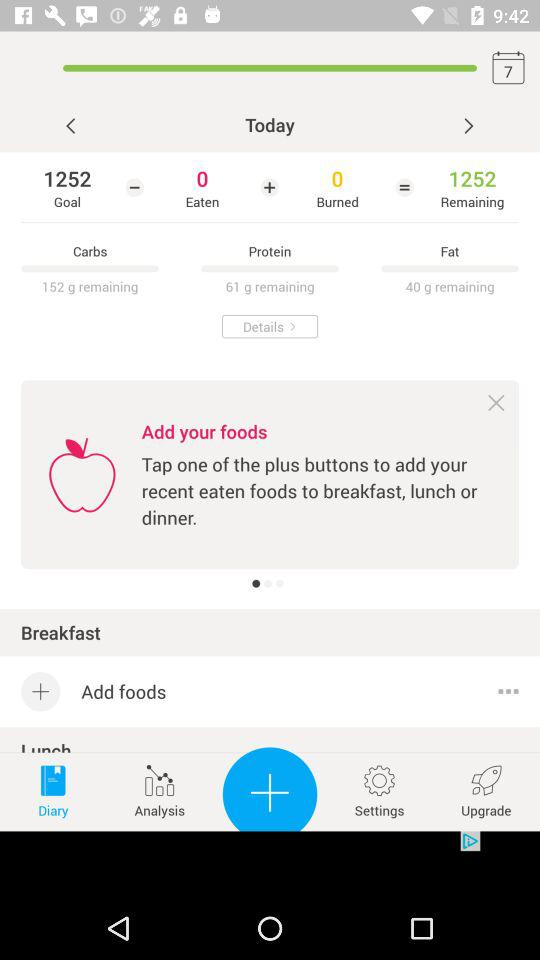How many calories are left?
Answer the question using a single word or phrase. 1252 